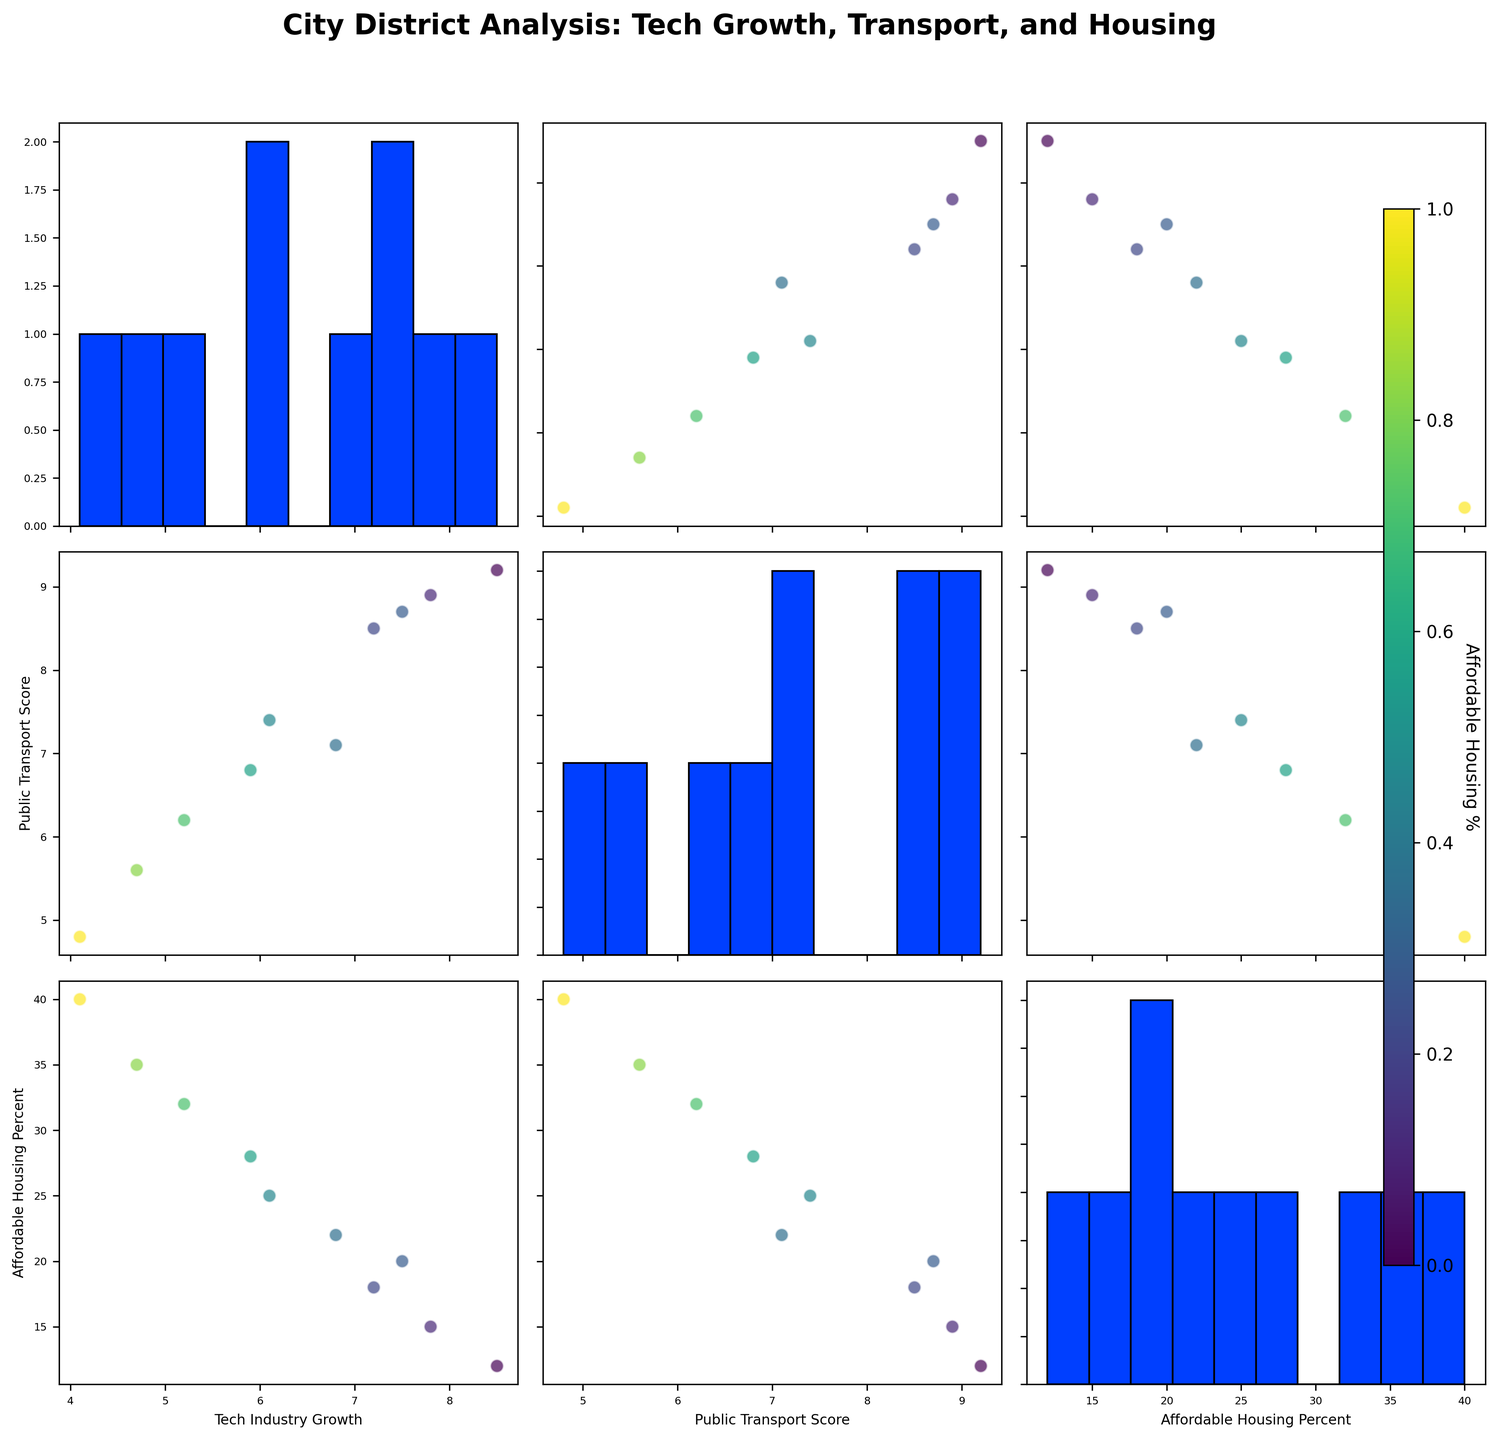How many districts are there with Tech Industry Growth scores above 7? We need to count the number of points with 'Tech_Industry_Growth' greater than 7 in any scatterplot involving this variable. Points with 'Tech_Industry_Growth' greater than 7 are Downtown, Midtown, Riverfront, and University.
Answer: 4 Which district has the highest Public Transport Score? Locate the highest value on any scatterplot or histogram involving 'Public_Transport_Score'. The highest score is 9.2 found in the Downtown district.
Answer: Downtown Is there a visible correlation between Tech Industry Growth and Public Transport Score? Look for a scatterplot comparing 'Tech_Industry_Growth' and 'Public_Transport_Score'. Check if there's a noticeable trend. Higher 'Public_Transport_Score' tends to align with higher 'Tech_Industry_Growth'.
Answer: Yes Which districts are outliers with very low Tech Industry Growth but high Affordable Housing Percent? Find scatterplots involving 'Tech_Industry_Growth' and 'Affordable_Housing_Percent'. Look for points with low 'Tech_Industry_Growth' and high 'Affordable_Housing_Percent'. Southend, Industrial, and Suburbs fit this category.
Answer: Southend, Industrial, Suburbs How does the Public Transport Score distribution look across all districts? Check the histograms along the diagonal for 'Public_Transport_Score'. Identify the spread and concentration of scores. The scores range mostly between 4.8 to 9.2, with fewer lower scores.
Answer: Ranges 4.8 to 9.2 Which district has the largest Affordable Housing Percent? Locate the highest value on any scatterplot or histogram involving 'Affordable_Housing_Percent'. The highest percentage is 40% in the Suburbs district.
Answer: Suburbs Are there any districts with a Public Transport Score higher than 8.5 and Tech Industry Growth lower than 7.5? Check scatterplots comparing 'Public_Transport_Score' with 'Tech_Industry_Growth'. Locate points with 'Public_Transport_Score' > 8.5 and 'Tech_Industry_Growth' < 7.5. There are none.
Answer: No Does higher Tech Industry Growth generally align with lower Affordable Housing Percent? Look for a scatterplot comparing 'Tech_Industry_Growth' with 'Affordable_Housing_Percent'. Check the trend whether higher tech growth aligns with lower affordable housing. The scatterplot shows a trend where higher tech growth aligns with lower affordable housing percentages.
Answer: Yes 